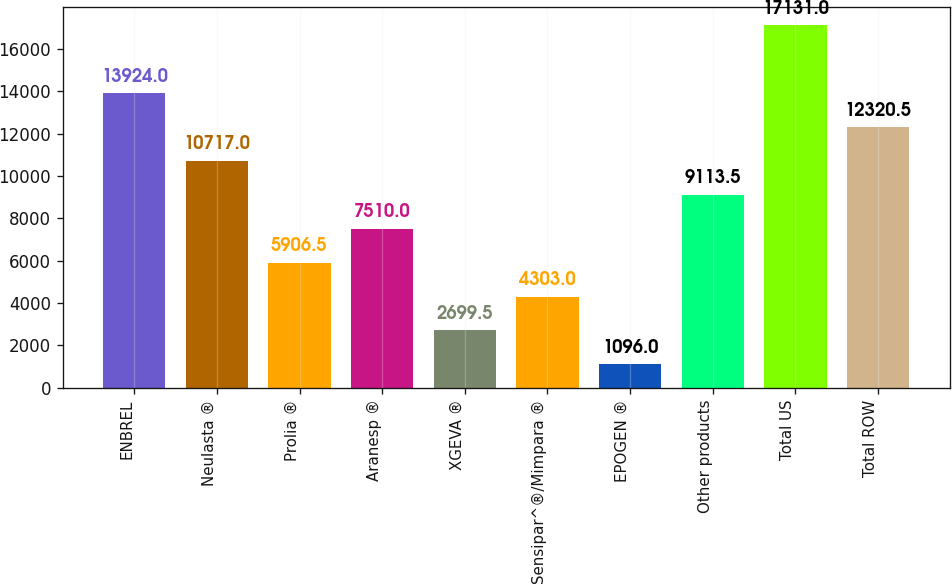Convert chart. <chart><loc_0><loc_0><loc_500><loc_500><bar_chart><fcel>ENBREL<fcel>Neulasta ®<fcel>Prolia ®<fcel>Aranesp ®<fcel>XGEVA ®<fcel>Sensipar^®/Mimpara ®<fcel>EPOGEN ®<fcel>Other products<fcel>Total US<fcel>Total ROW<nl><fcel>13924<fcel>10717<fcel>5906.5<fcel>7510<fcel>2699.5<fcel>4303<fcel>1096<fcel>9113.5<fcel>17131<fcel>12320.5<nl></chart> 